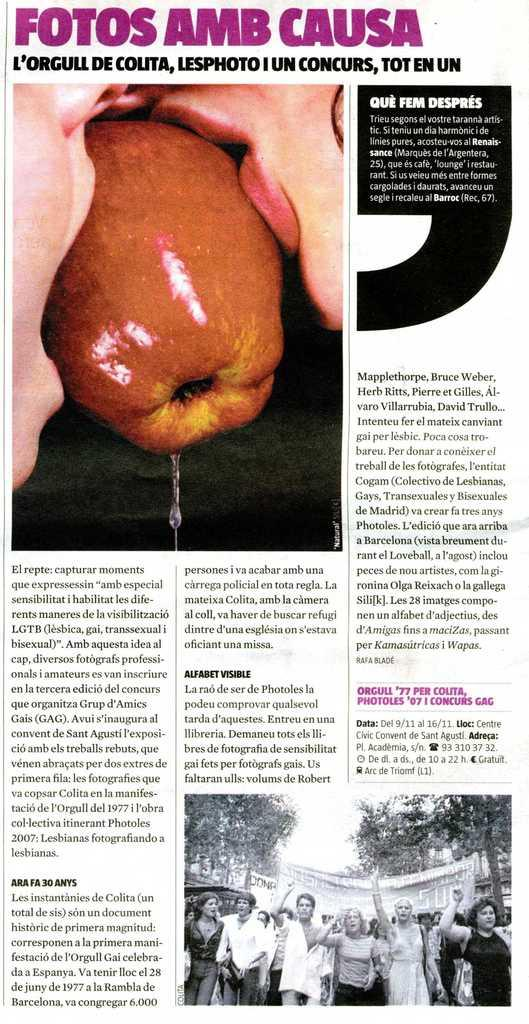<image>
Summarize the visual content of the image. A page from a magazine has the title Fotos Amb Causa. 